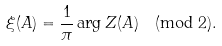Convert formula to latex. <formula><loc_0><loc_0><loc_500><loc_500>\xi ( A ) = \frac { 1 } { \pi } \arg Z ( A ) \pmod { 2 } .</formula> 